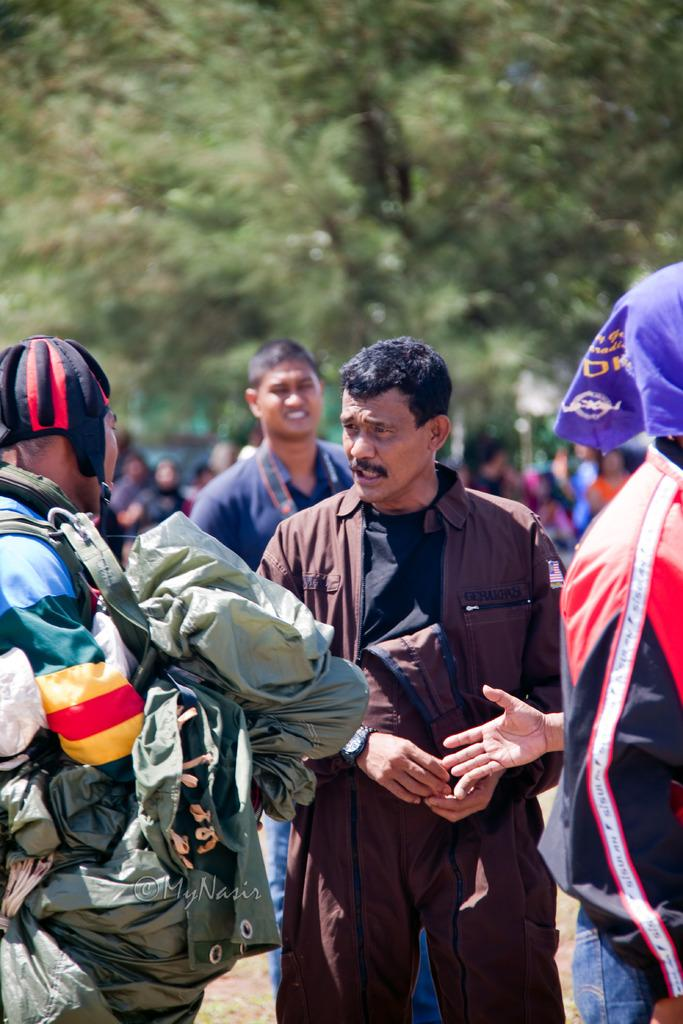How many persons can be seen in the image? There are persons in the image, but the exact number is not specified. What protective gear is visible in the image? There is at least one helmet in the image. What other objects can be seen in the image? There are other objects in the image, but their specific nature is not mentioned. Can you describe the background of the image? There are persons and trees in the background of the image, along with other objects. What type of haircut is the person in the image getting? There is no indication in the image that a haircut is taking place, so it cannot be determined from the picture. 